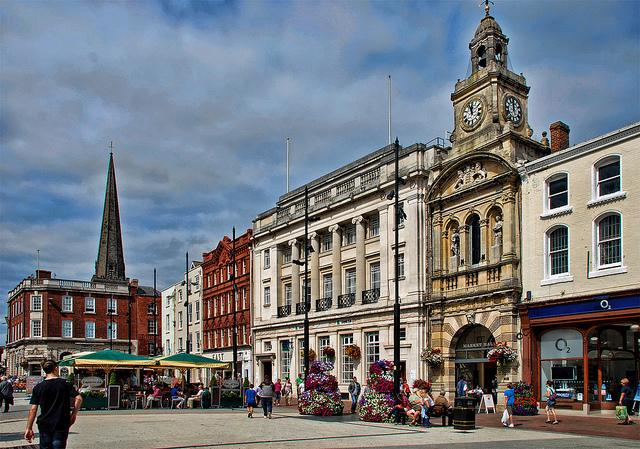How many clock faces can be seen on the clock tower? Please explain your reasoning. two. Two clock faces are on the front and side. 